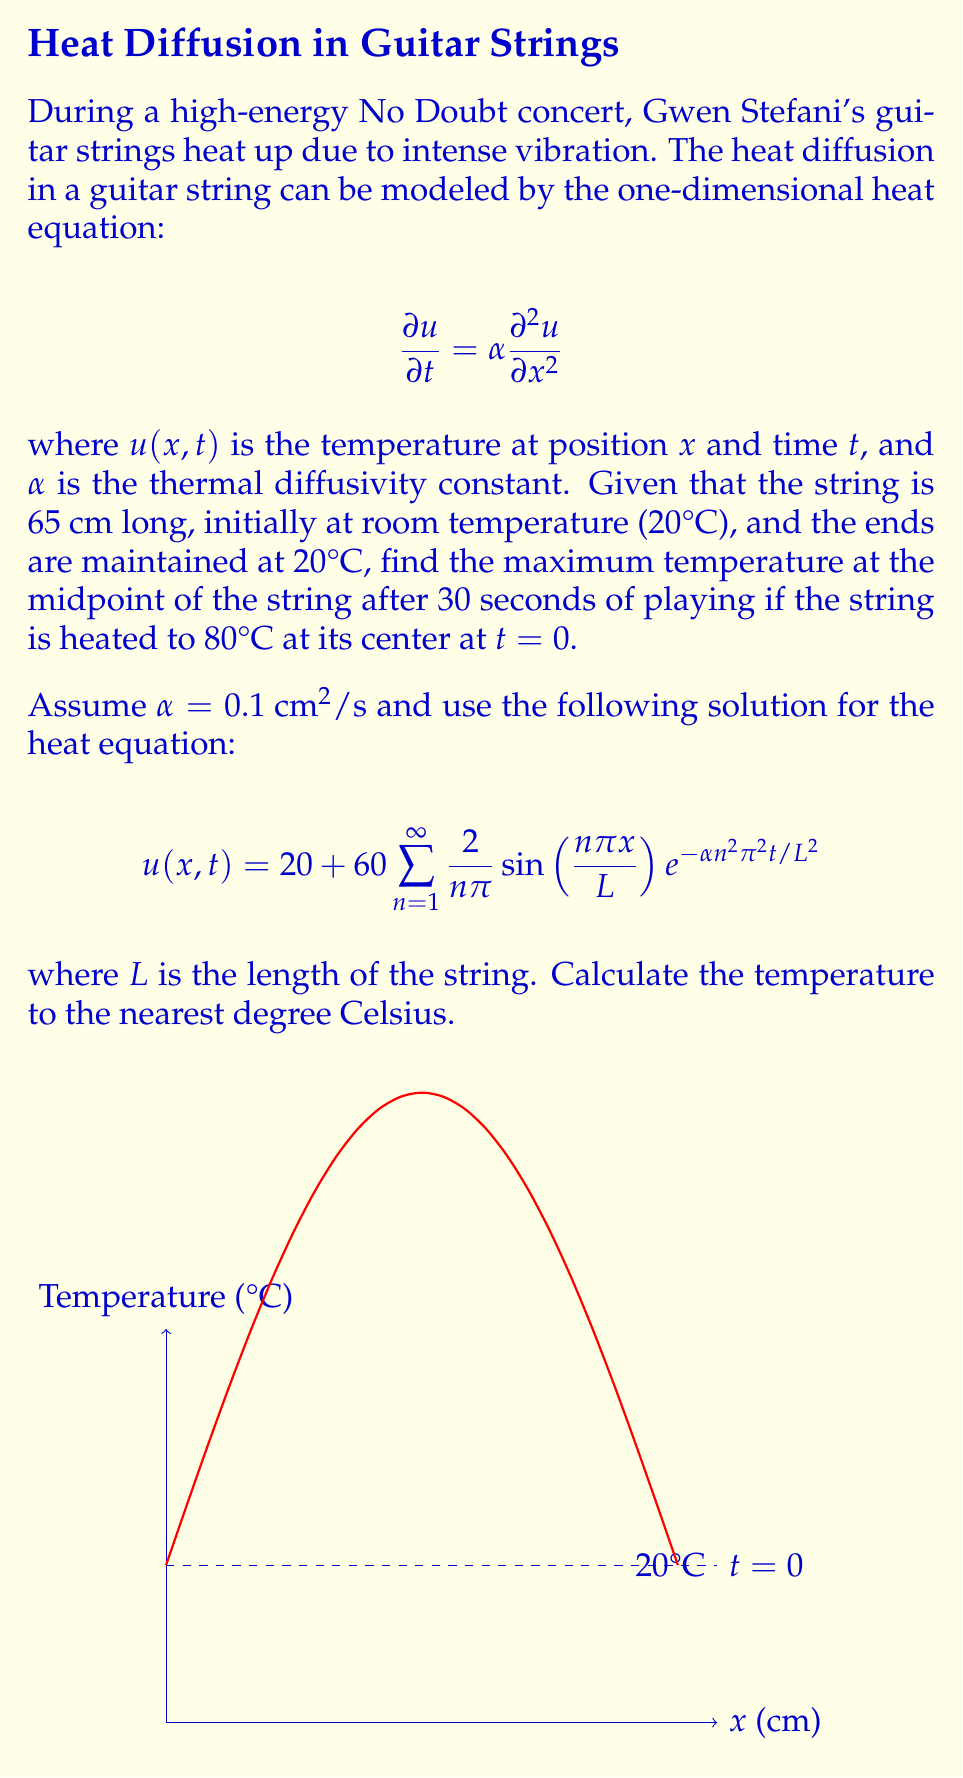Help me with this question. Let's approach this step-by-step:

1) We're given the solution for the heat equation:
   $$u(x,t) = 20 + 60 \sum_{n=1}^{\infty} \frac{2}{n\pi} \sin\left(\frac{n\pi x}{L}\right) e^{-\alpha n^2 \pi^2 t / L^2}$$

2) We need to find $u(L/2, 30)$, where $L = 65$ cm and $\alpha = 0.1 \text{ cm}^2/\text{s}$.

3) Substituting these values:
   $$u(32.5, 30) = 20 + 60 \sum_{n=1}^{\infty} \frac{2}{n\pi} \sin\left(\frac{n\pi 32.5}{65}\right) e^{-0.1 n^2 \pi^2 30 / 65^2}$$

4) Simplify the argument of sine:
   $$\sin\left(\frac{n\pi 32.5}{65}\right) = \sin\left(\frac{n\pi}{2}\right)$$

5) This equals 1 when $n$ is odd and 0 when $n$ is even. So we only need to sum over odd $n$:
   $$u(32.5, 30) = 20 + 60 \sum_{n=1,3,5,...}^{\infty} \frac{2}{n\pi} e^{-0.1 n^2 \pi^2 30 / 65^2}$$

6) Let's calculate the first few terms:
   For $n=1$: $\frac{2}{\pi} e^{-0.1 \pi^2 30 / 65^2} \approx 0.5978$
   For $n=3$: $\frac{2}{3\pi} e^{-0.1 9\pi^2 30 / 65^2} \approx 0.0009$
   For $n=5$: $\frac{2}{5\pi} e^{-0.1 25\pi^2 30 / 65^2} \approx 0.0000$

7) We can see that terms for $n \geq 3$ are negligibly small, so we'll only use the first term:
   $$u(32.5, 30) \approx 20 + 60 \cdot 0.5978 = 55.87°C$$

8) Rounding to the nearest degree:
   $$u(32.5, 30) \approx 56°C$$
Answer: 56°C 